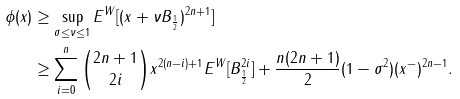<formula> <loc_0><loc_0><loc_500><loc_500>\phi ( x ) & \geq \sup _ { \sigma \leq \nu \leq 1 } E ^ { W } [ ( x + \nu B _ { \frac { 1 } { 2 } } ) ^ { 2 n + 1 } ] \\ & \geq \sum _ { i = 0 } ^ { n } \binom { 2 n + 1 } { 2 i } x ^ { 2 ( n - i ) + 1 } E ^ { W } [ B _ { \frac { 1 } { 2 } } ^ { 2 i } ] + \frac { n ( 2 n + 1 ) } { 2 } ( 1 - \sigma ^ { 2 } ) ( x ^ { - } ) ^ { 2 n - 1 } .</formula> 